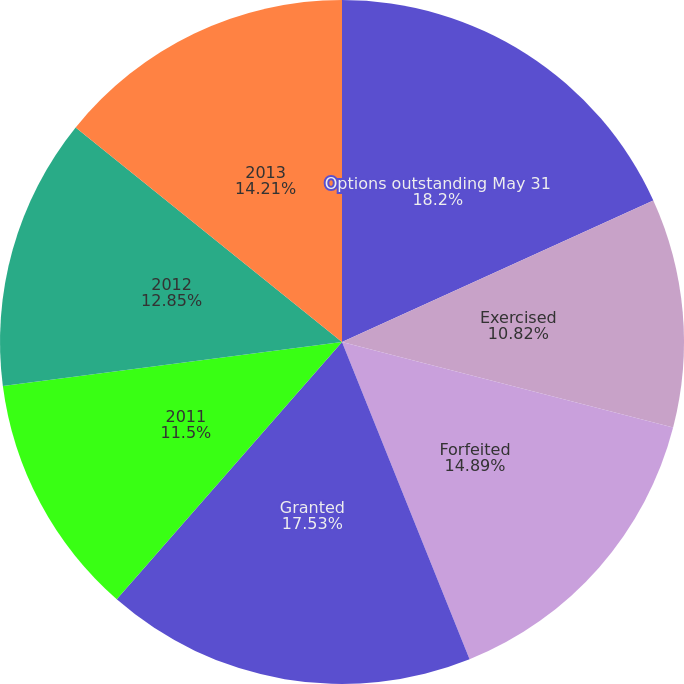Convert chart to OTSL. <chart><loc_0><loc_0><loc_500><loc_500><pie_chart><fcel>Options outstanding May 31<fcel>Exercised<fcel>Forfeited<fcel>Granted<fcel>2011<fcel>2012<fcel>2013<nl><fcel>18.21%<fcel>10.82%<fcel>14.89%<fcel>17.53%<fcel>11.5%<fcel>12.85%<fcel>14.21%<nl></chart> 